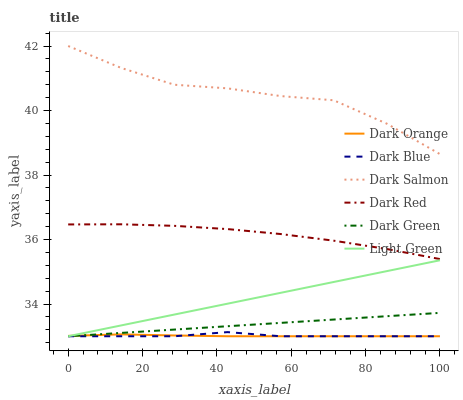Does Dark Orange have the minimum area under the curve?
Answer yes or no. Yes. Does Dark Salmon have the maximum area under the curve?
Answer yes or no. Yes. Does Dark Red have the minimum area under the curve?
Answer yes or no. No. Does Dark Red have the maximum area under the curve?
Answer yes or no. No. Is Light Green the smoothest?
Answer yes or no. Yes. Is Dark Salmon the roughest?
Answer yes or no. Yes. Is Dark Red the smoothest?
Answer yes or no. No. Is Dark Red the roughest?
Answer yes or no. No. Does Dark Red have the lowest value?
Answer yes or no. No. Does Dark Red have the highest value?
Answer yes or no. No. Is Dark Blue less than Dark Red?
Answer yes or no. Yes. Is Dark Red greater than Dark Green?
Answer yes or no. Yes. Does Dark Blue intersect Dark Red?
Answer yes or no. No. 